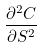<formula> <loc_0><loc_0><loc_500><loc_500>\frac { \partial ^ { 2 } C } { \partial S ^ { 2 } }</formula> 